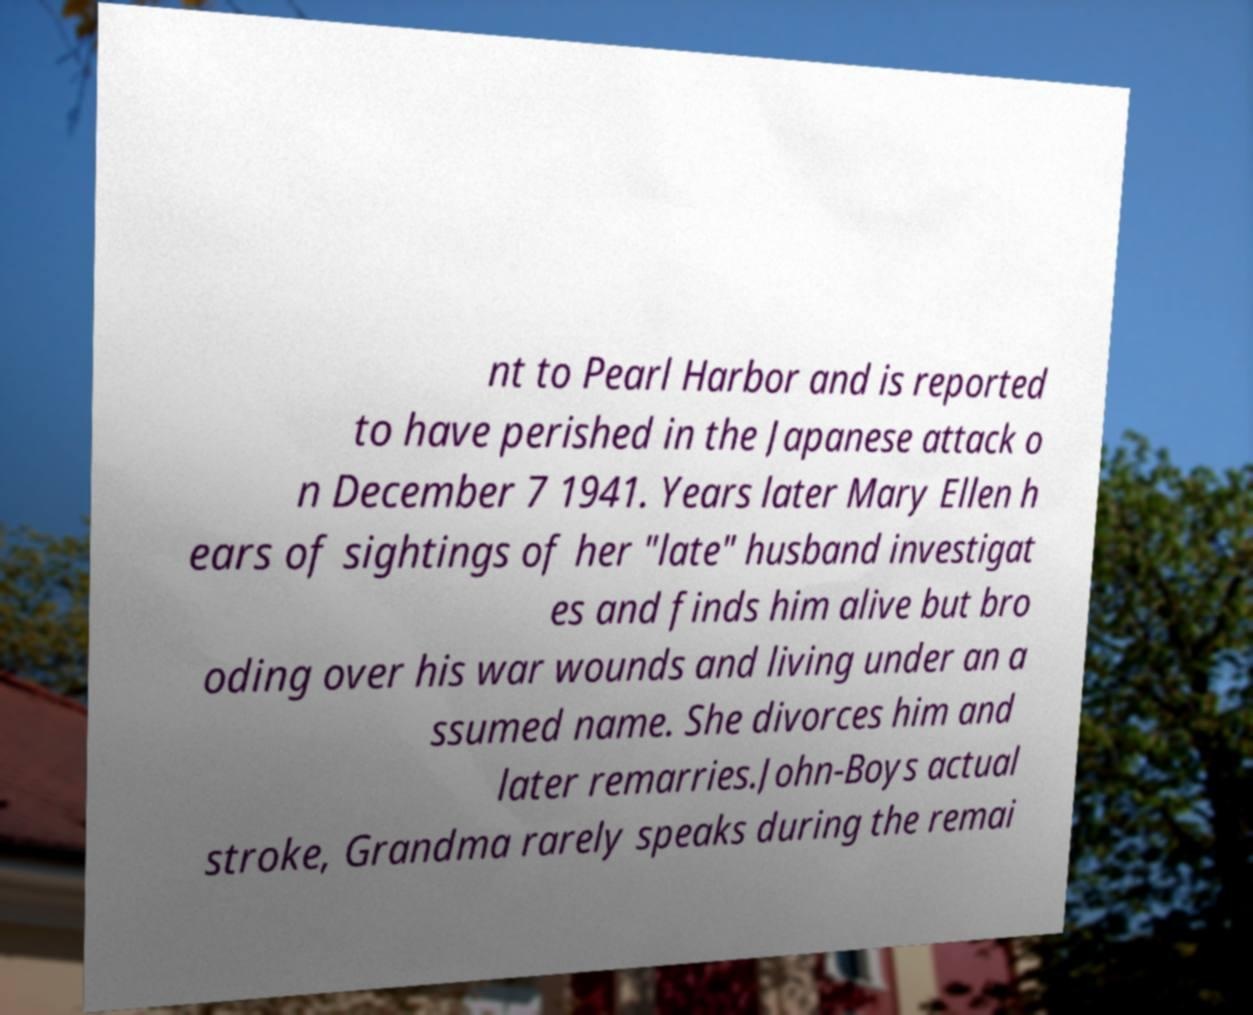Could you extract and type out the text from this image? nt to Pearl Harbor and is reported to have perished in the Japanese attack o n December 7 1941. Years later Mary Ellen h ears of sightings of her "late" husband investigat es and finds him alive but bro oding over his war wounds and living under an a ssumed name. She divorces him and later remarries.John-Boys actual stroke, Grandma rarely speaks during the remai 